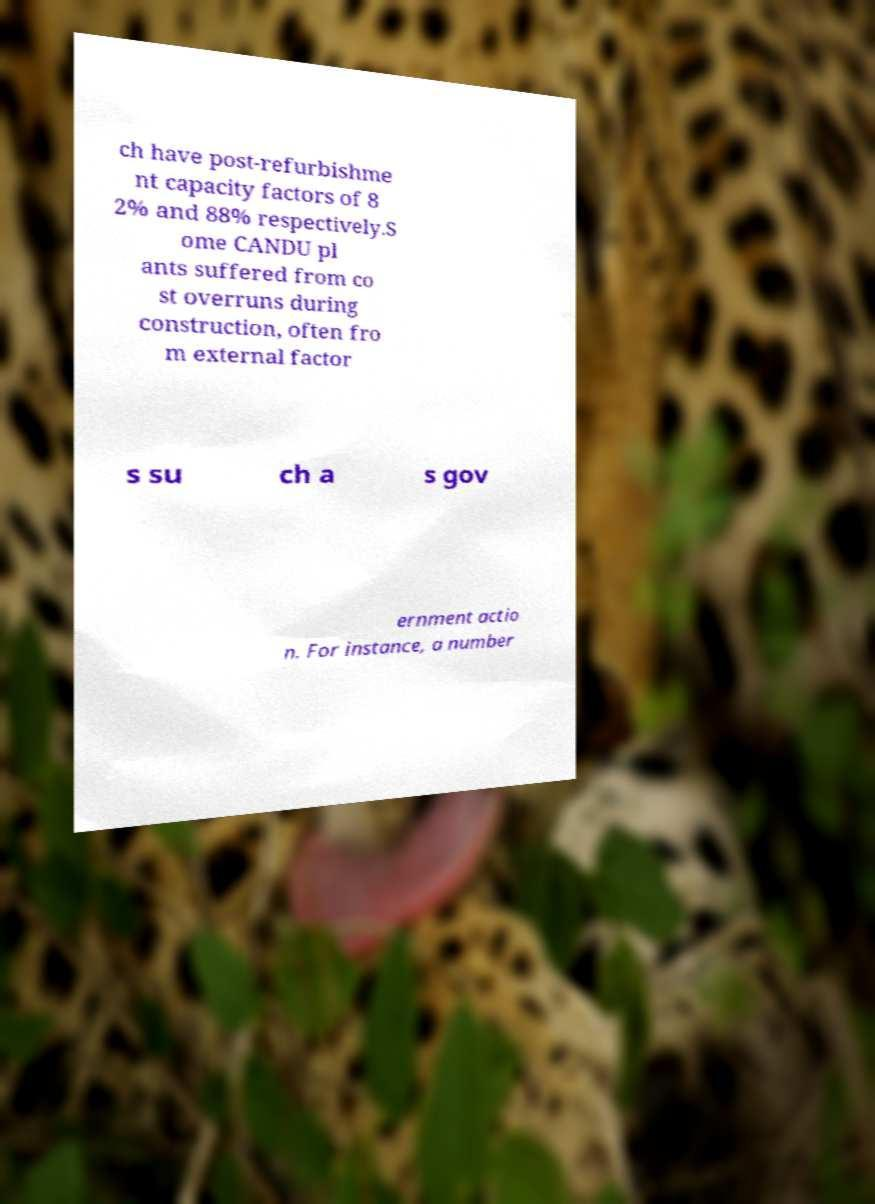For documentation purposes, I need the text within this image transcribed. Could you provide that? ch have post-refurbishme nt capacity factors of 8 2% and 88% respectively.S ome CANDU pl ants suffered from co st overruns during construction, often fro m external factor s su ch a s gov ernment actio n. For instance, a number 